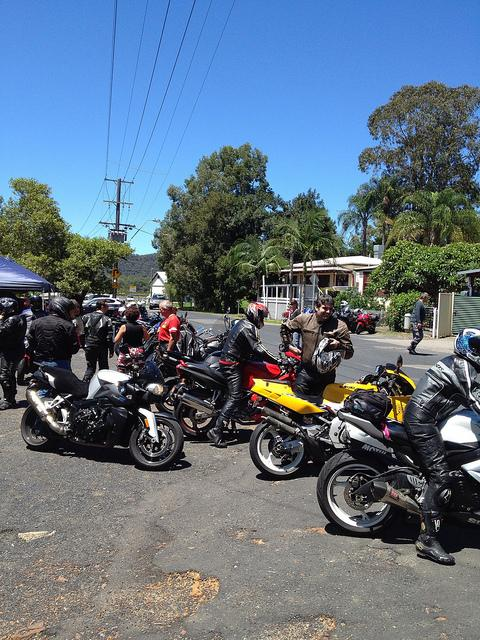What type weather is typical here? sunny 